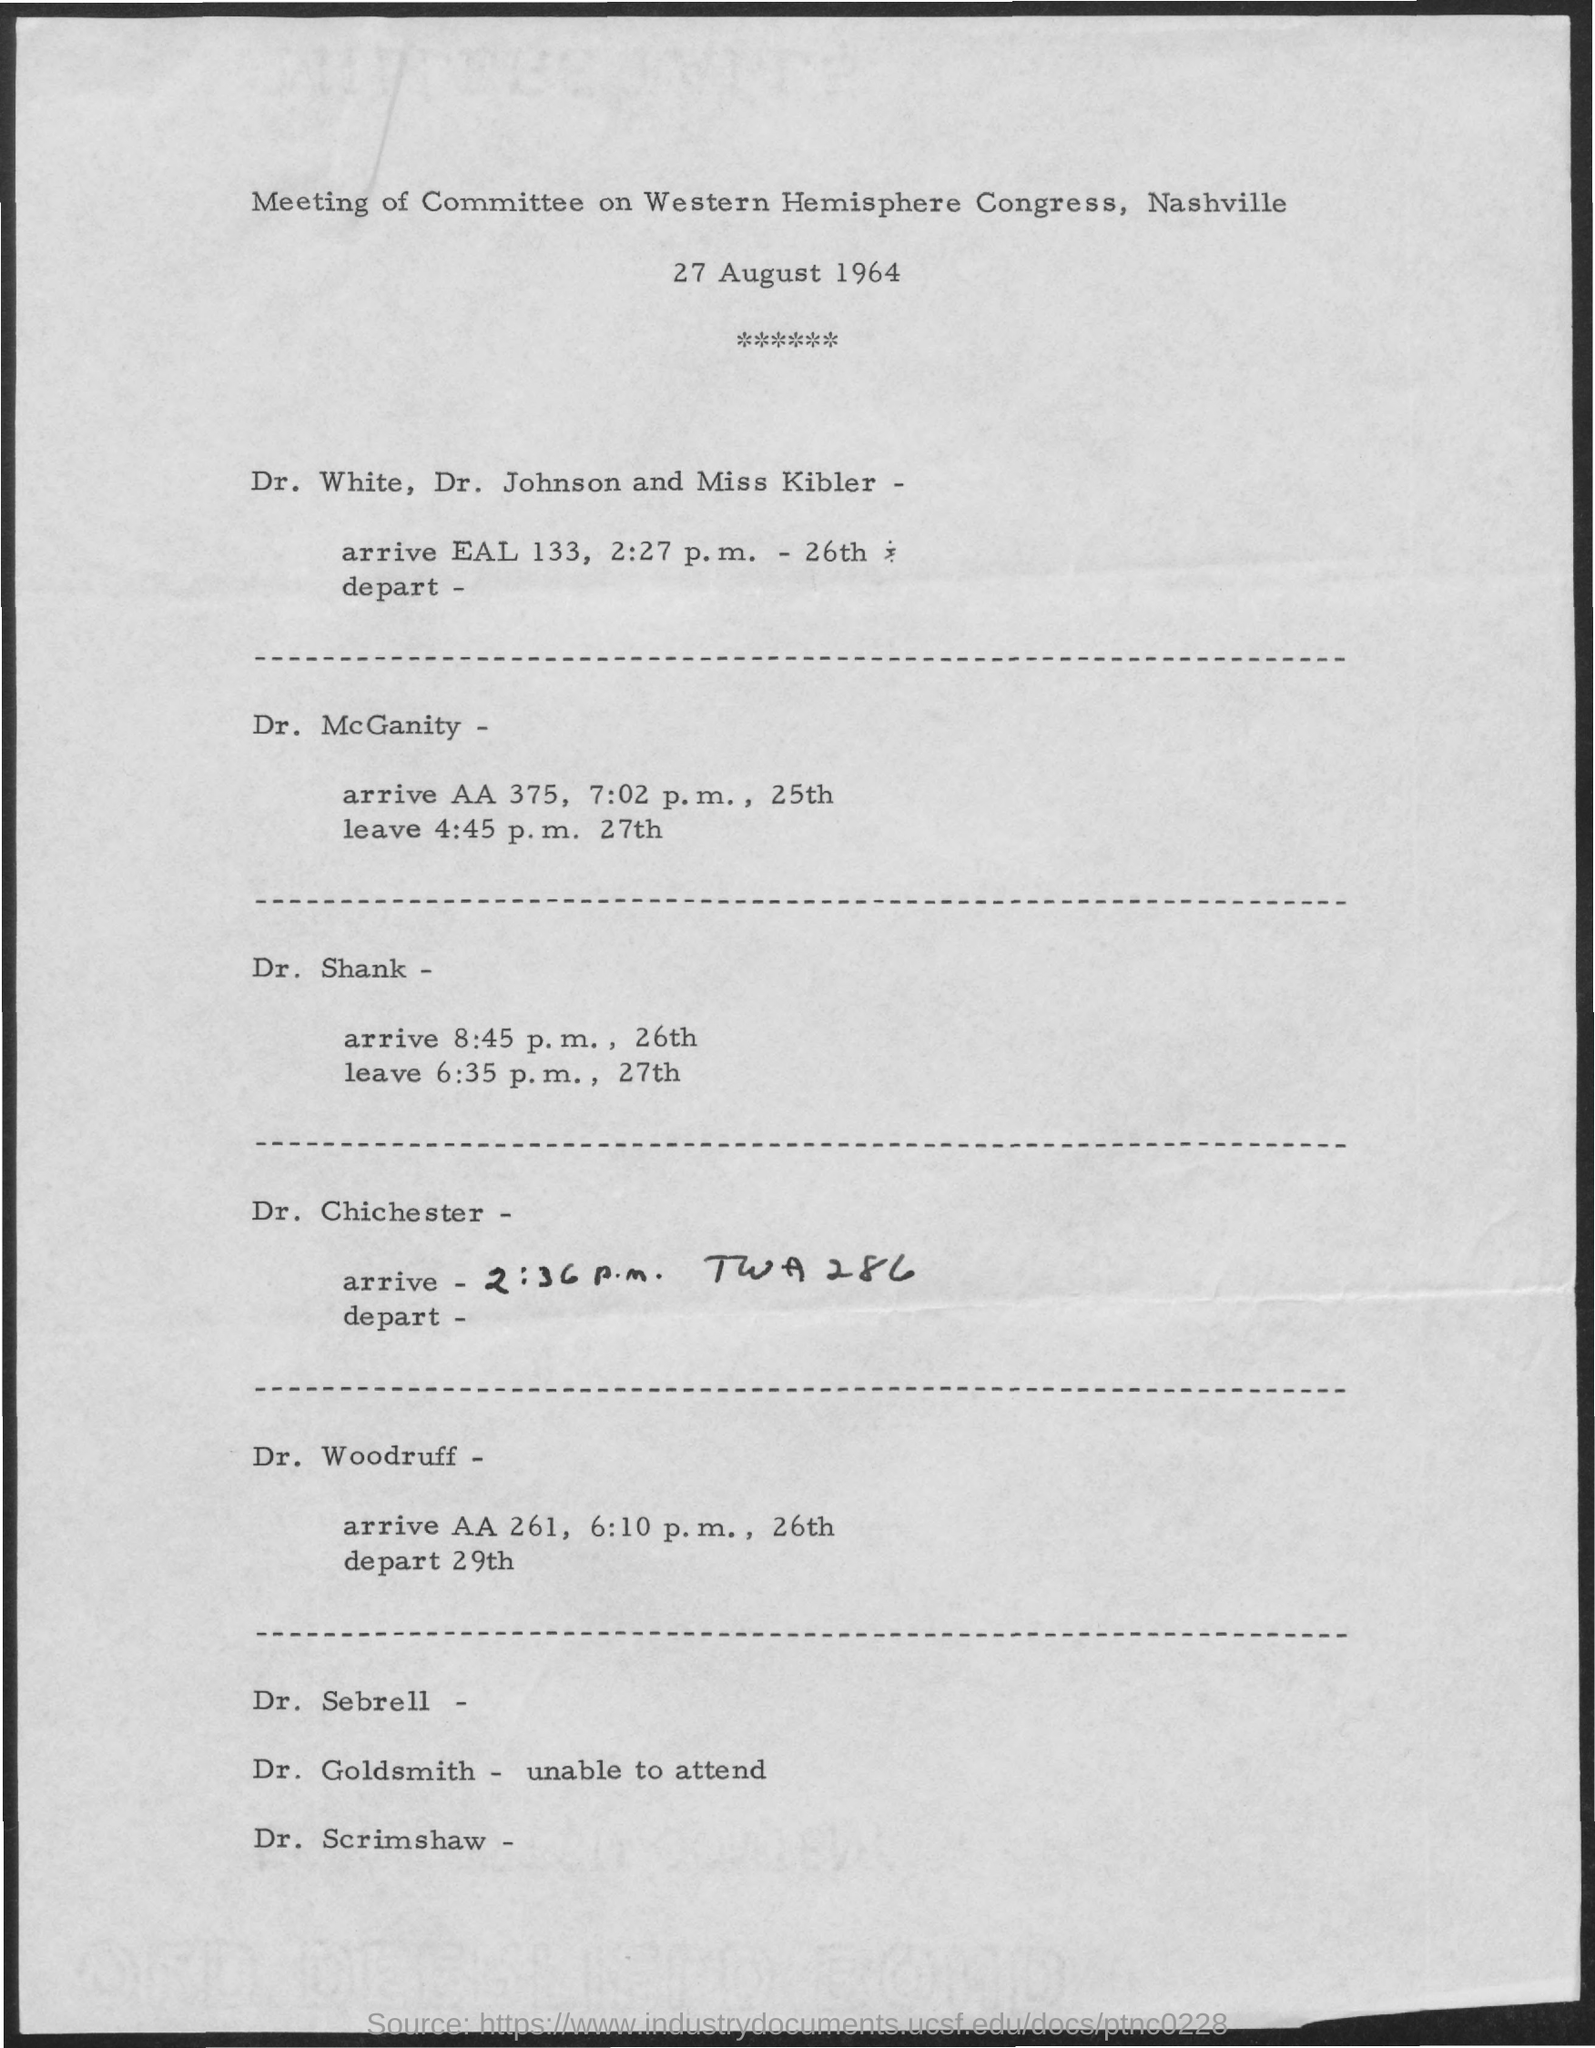When is the Meeting of Committee on Western Hemisphere Congress, Nashville held?
Provide a short and direct response. 27 August, 1964. 